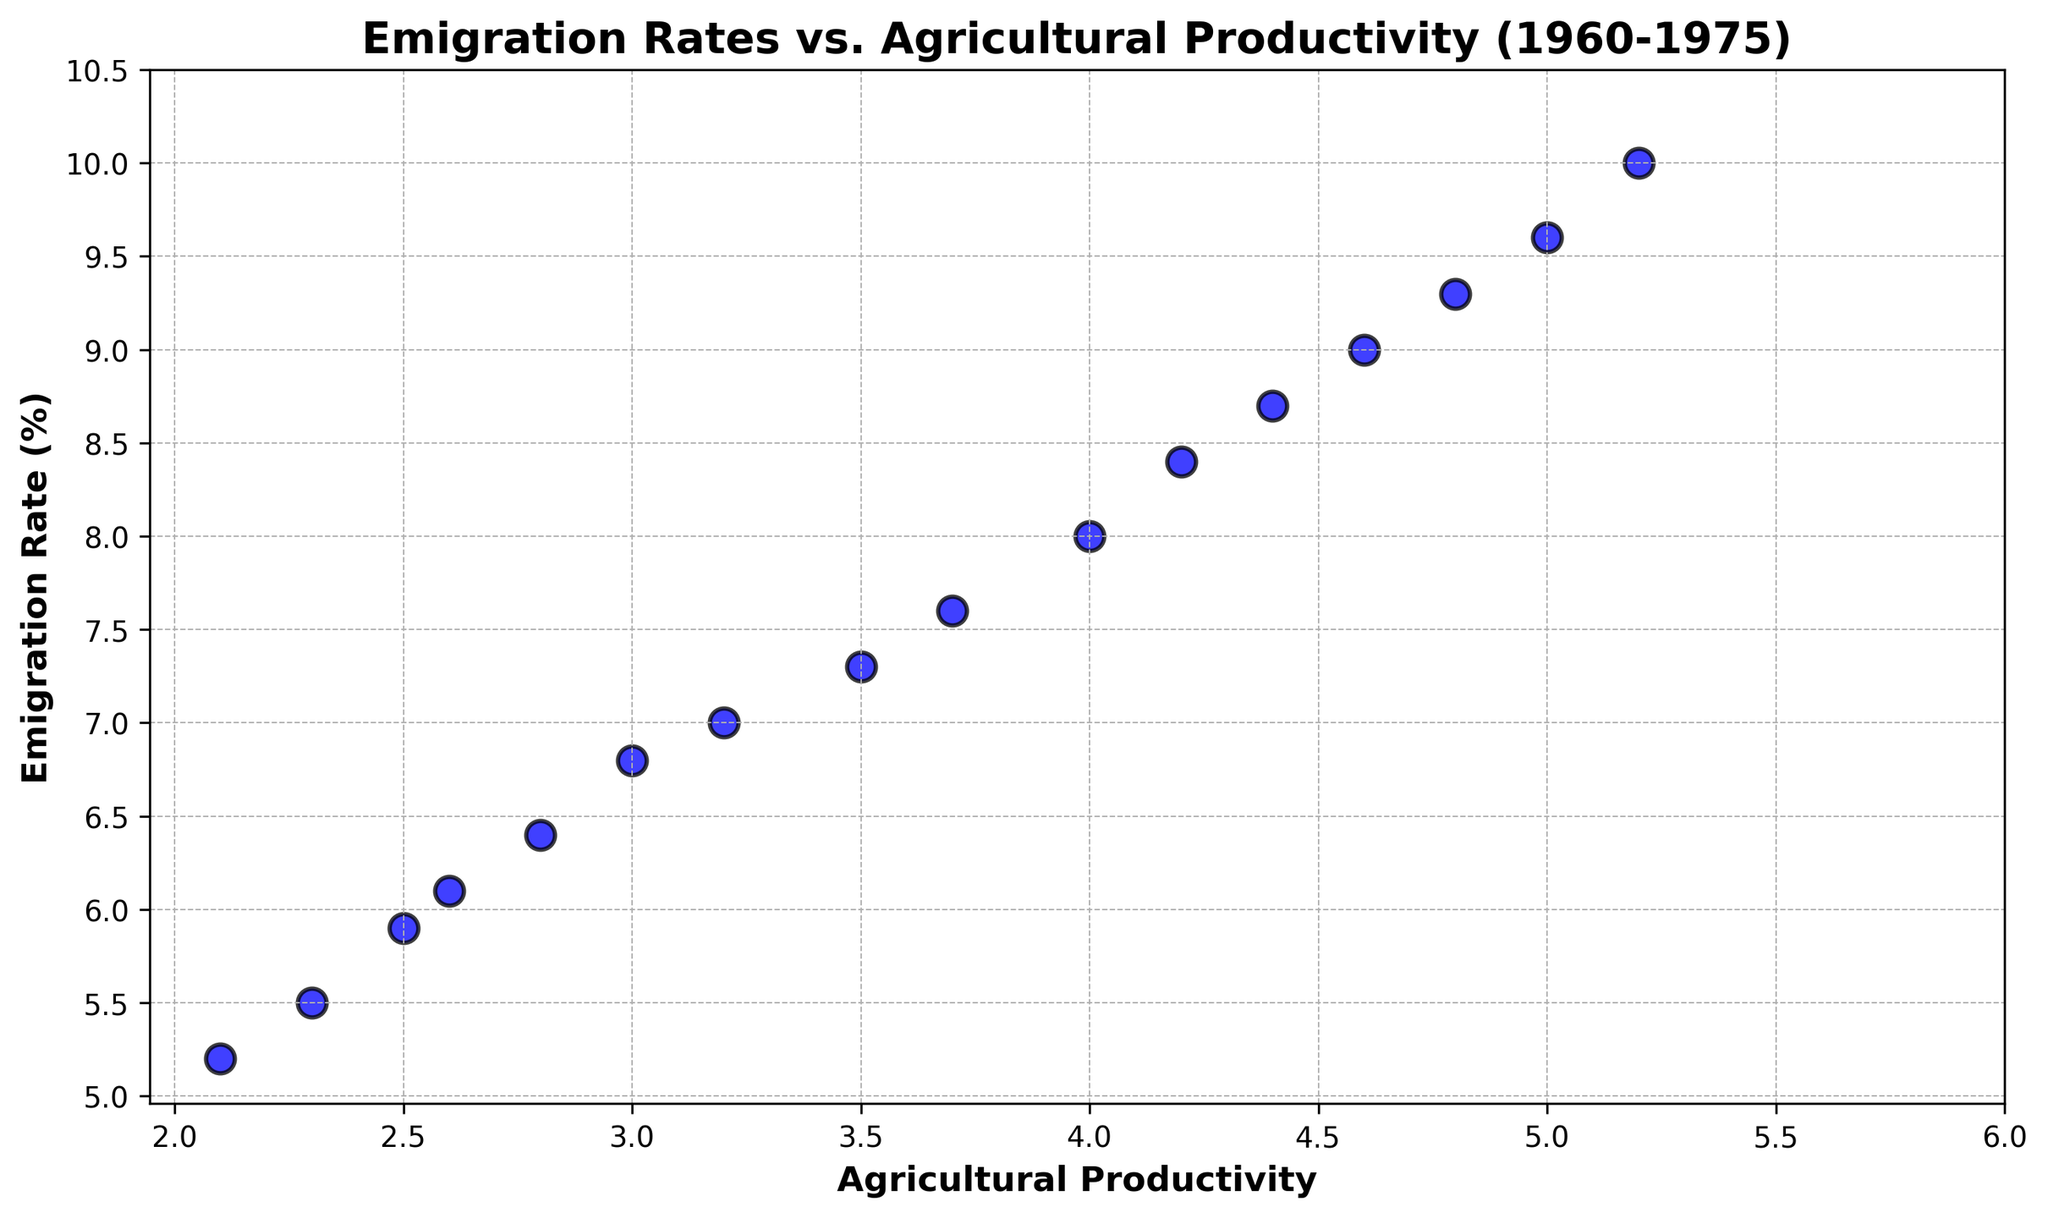What is the relationship between the emigration rate and agricultural productivity? The scatter plot shows a positive trend, where higher agricultural productivity is associated with higher emigration rates. This can be observed as the data points trend upwards from left to right.
Answer: Positive correlation Which year had the highest emigration rate and what was the agricultural productivity in that year? The year with the highest emigration rate is 1975. In 1975, the emigration rate is 10%, and the corresponding agricultural productivity is 5.2.
Answer: 1975, productivity: 5.2 How much did the emigration rate increase from 1960 to 1965? In 1960, the emigration rate was 5.2%. By 1965, it had increased to 6.8%. The increase is calculated by subtracting the former from the latter: 6.8 - 5.2 = 1.6%.
Answer: 1.6% Which year had the lowest agricultural productivity, and what was the emigration rate that year? The year with the lowest agricultural productivity is 1960. In 1960, the agricultural productivity is 2.1, and the corresponding emigration rate is 5.2%.
Answer: 1960, emigration rate: 5.2% What was the average agricultural productivity from 1960 to 1965? The agricultural productivity values from 1960 to 1965 are 2.1, 2.3, 2.5, 2.6, 2.8, and 3.0. The sum of these values is 15.3. To find the average, divide by the number of years (6): 15.3 / 6 ≈ 2.55.
Answer: 2.55 In which year did both the emigration rate and agricultural productivity first exceed 7.0 and 3.0 respectively? The emigration rate first exceeds 7.0 and agricultural productivity first exceeds 3.0 in the year 1966. In 1966, the emigration rate is 7.0% and agricultural productivity is 3.2.
Answer: 1966 How does the emigration rate change as agricultural productivity increases from 2.1 to 5.2? As agricultural productivity increases from 2.1 to 5.2, the emigration rate increases from 5.2% to 10%. This indicates that higher agricultural productivity is associated with higher emigration rates throughout this range.
Answer: Increases Considering the correlation observed, predict the emigration rate if the agricultural productivity were 6.0. Given the positive correlation observed between agricultural productivity and emigration rate, if agricultural productivity were 6.0, it would likely result in an emigration rate slightly above 10%, as productivity values near 5.2 have an emigration rate of 10%.
Answer: Slightly above 10% Between which consecutive years did agricultural productivity see the highest increase, and what was the rate of increase? The highest increase in agricultural productivity occurs between 1974 and 1975. Productivity increased from 5.0 to 5.2 during this period. The rate of increase is calculated as 5.2 - 5.0 = 0.2.
Answer: 1974-1975, increase: 0.2 